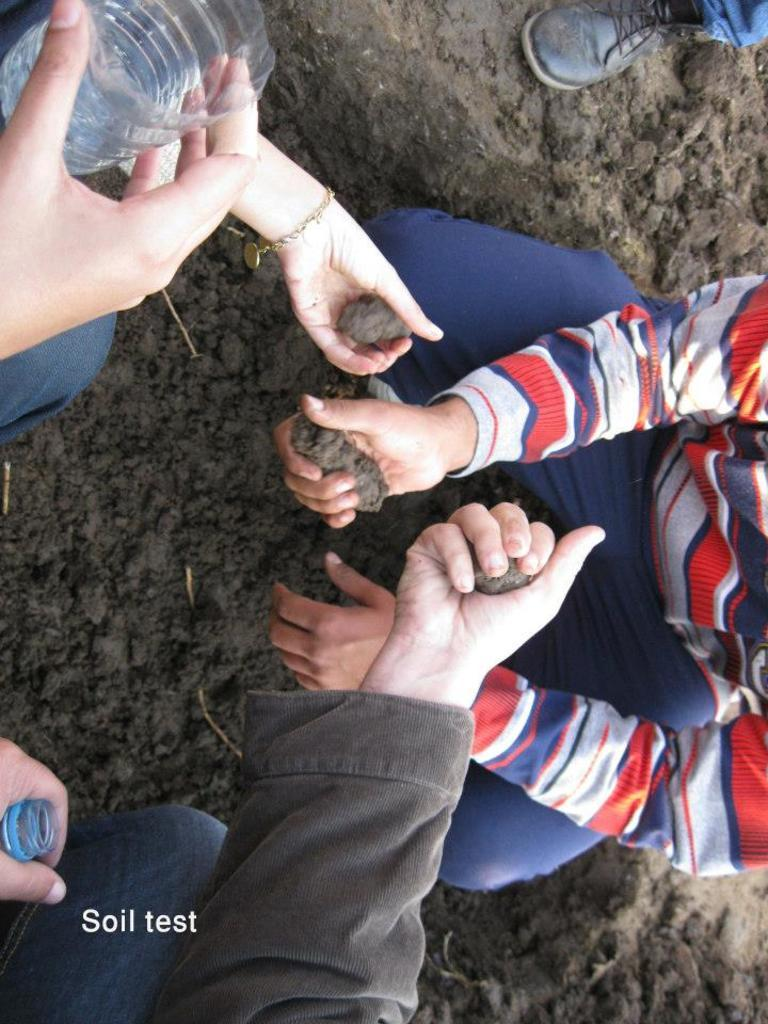What are the three people in the image doing? The three people in the image are holding soil. What objects can be seen in the image besides the people? There are plastic water bottles and soil on the ground visible in the image. Can you describe any other item in the image? Yes, there is a shoe visible in the image. What type of system is the ant using to communicate with the other ants in the image? There are no ants present in the image, so it is not possible to determine what type of system they might be using to communicate. 